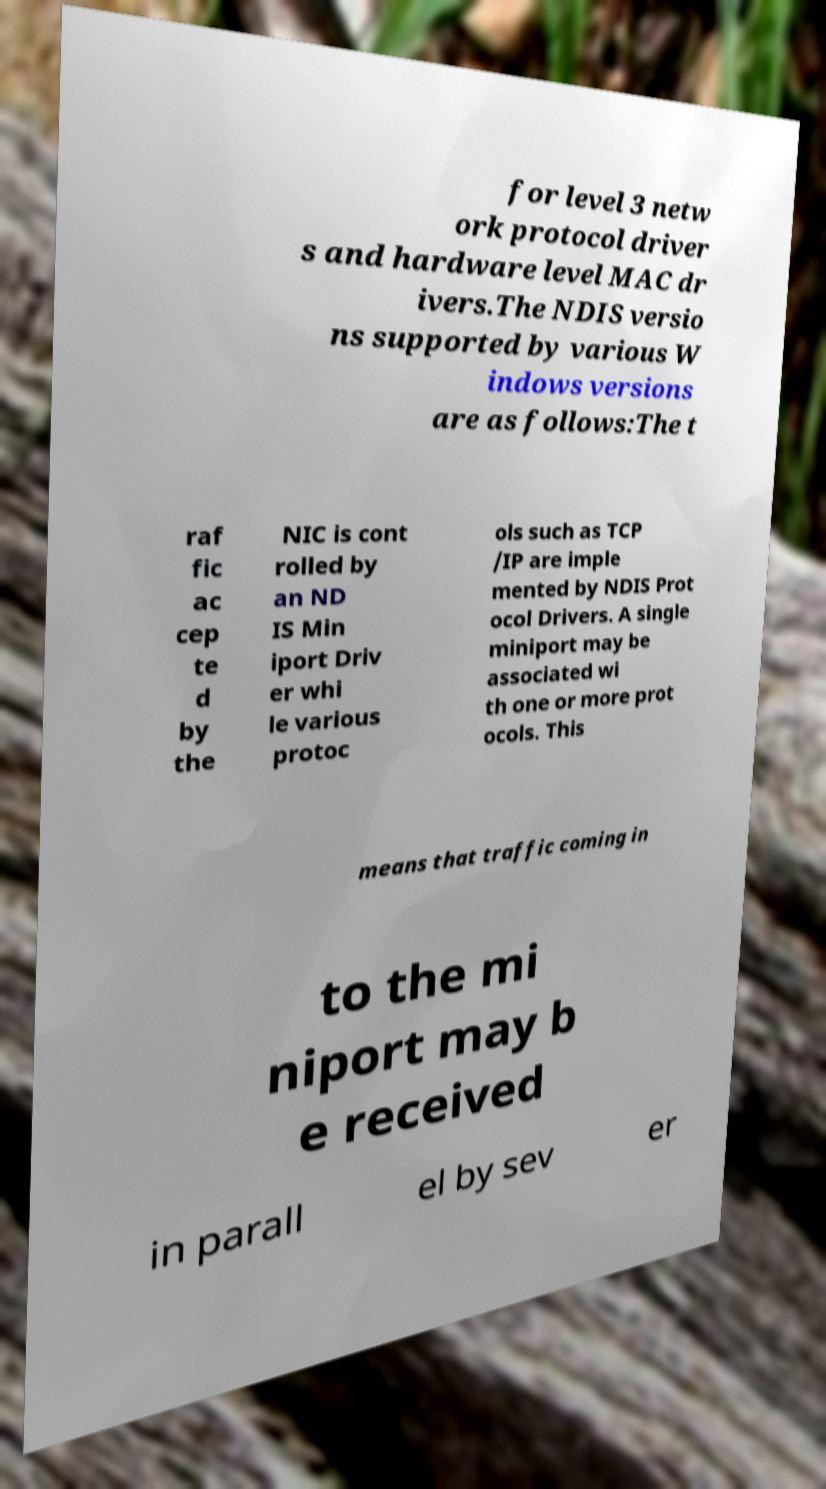Can you accurately transcribe the text from the provided image for me? for level 3 netw ork protocol driver s and hardware level MAC dr ivers.The NDIS versio ns supported by various W indows versions are as follows:The t raf fic ac cep te d by the NIC is cont rolled by an ND IS Min iport Driv er whi le various protoc ols such as TCP /IP are imple mented by NDIS Prot ocol Drivers. A single miniport may be associated wi th one or more prot ocols. This means that traffic coming in to the mi niport may b e received in parall el by sev er 